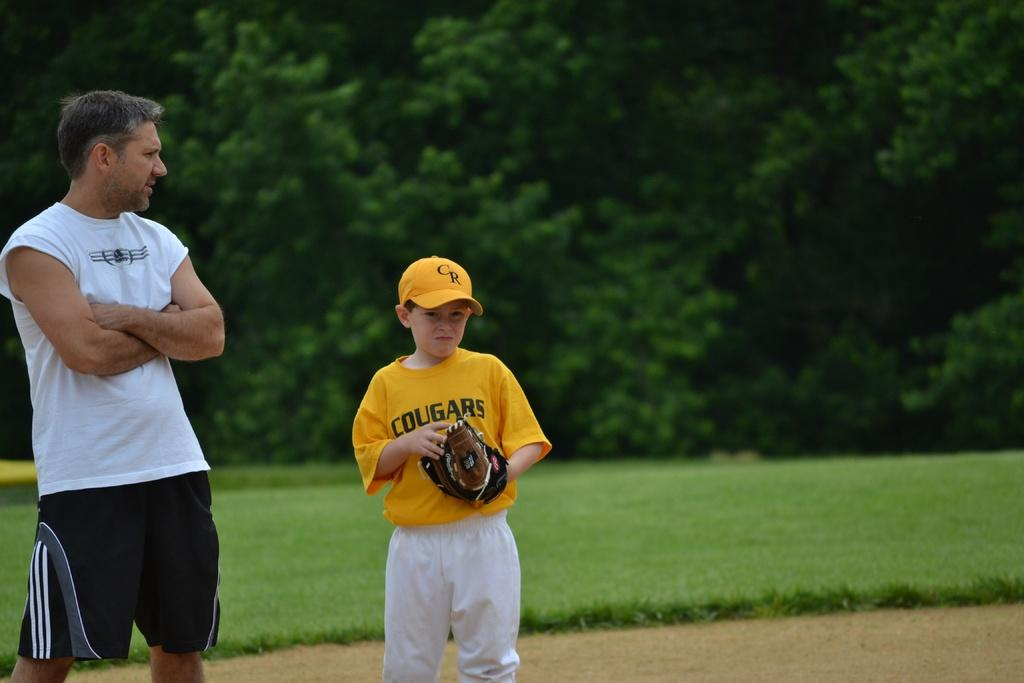<image>
Describe the image concisely. A young baseball player wears a cougars uniform. 